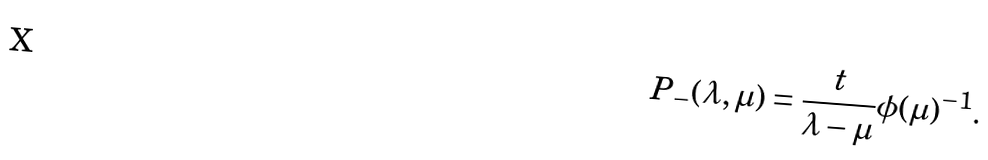<formula> <loc_0><loc_0><loc_500><loc_500>P _ { - } ( \lambda , \mu ) = \frac { t } { \lambda - \mu } \phi ( \mu ) ^ { - 1 } .</formula> 